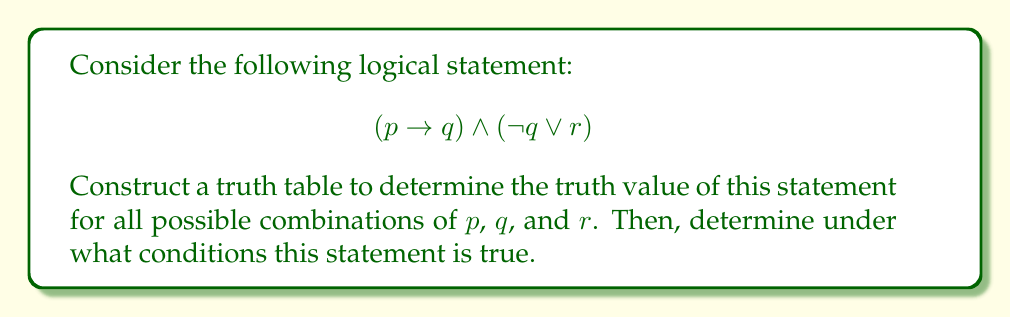Solve this math problem. To solve this problem, we'll follow these steps:

1. Identify the atomic propositions: $p$, $q$, and $r$
2. List all possible combinations of truth values for these propositions
3. Evaluate each subexpression
4. Combine the results to get the final truth value

Let's create the truth table:

1. First, we'll list all possible combinations of $p$, $q$, and $r$:

   | $p$ | $q$ | $r$ |
   |-----|-----|-----|
   | T   | T   | T   |
   | T   | T   | F   |
   | T   | F   | T   |
   | T   | F   | F   |
   | F   | T   | T   |
   | F   | T   | F   |
   | F   | F   | T   |
   | F   | F   | F   |

2. Now, let's evaluate $(p \rightarrow q)$:

   | $p$ | $q$ | $(p \rightarrow q)$ |
   |-----|-----|---------------------|
   | T   | T   | T                   |
   | T   | F   | F                   |
   | F   | T   | T                   |
   | F   | F   | T                   |

3. Next, we'll evaluate $(\neg q \lor r)$:

   | $q$ | $r$ | $\neg q$ | $(\neg q \lor r)$ |
   |-----|-----|----------|-------------------|
   | T   | T   | F        | T                 |
   | T   | F   | F        | F                 |
   | F   | T   | T        | T                 |
   | F   | F   | T        | T                 |

4. Finally, we'll combine these results using $\land$ (AND):

   | $p$ | $q$ | $r$ | $(p \rightarrow q)$ | $(\neg q \lor r)$ | $(p \rightarrow q) \land (\neg q \lor r)$ |
   |-----|-----|-----|---------------------|-------------------|-------------------------------------------|
   | T   | T   | T   | T                   | T                 | T                                         |
   | T   | T   | F   | T                   | F                 | F                                         |
   | T   | F   | T   | F                   | T                 | F                                         |
   | T   | F   | F   | F                   | T                 | F                                         |
   | F   | T   | T   | T                   | T                 | T                                         |
   | F   | T   | F   | T                   | F                 | F                                         |
   | F   | F   | T   | T                   | T                 | T                                         |
   | F   | F   | F   | T                   | T                 | T                                         |

From this truth table, we can see that the statement is true in the following cases:
1. When $p$ is true, $q$ is true, and $r$ is true
2. When $p$ is false, $q$ is true, and $r$ is true
3. When $p$ is false, $q$ is false, and $r$ is true
4. When $p$ is false, $q$ is false, and $r$ is false
Answer: The logical statement $(p \rightarrow q) \land (\neg q \lor r)$ is true when:
1. $p$ is true, $q$ is true, and $r$ is true
2. $p$ is false, $q$ is true, and $r$ is true
3. $p$ is false, $q$ is false, and $r$ is true
4. $p$ is false, $q$ is false, and $r$ is false

In other words, it is true whenever $p$ is false, or when all three propositions are true. 